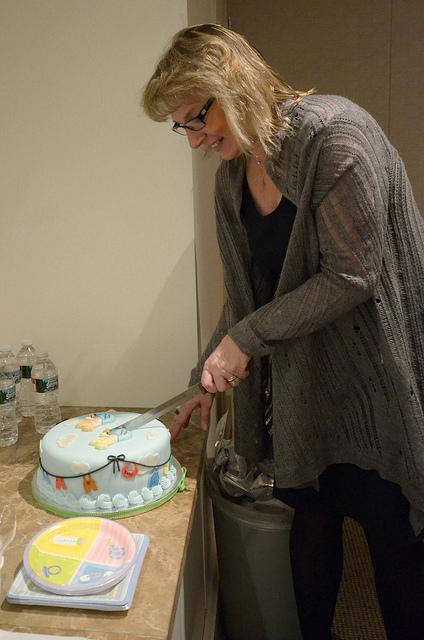What is on the women's face?
Be succinct. Glasses. Is this a homemade cake?
Concise answer only. No. Is the cake blue?
Short answer required. Yes. Is this person cutting a cake?
Quick response, please. Yes. What is the theme of the cake?
Be succinct. Baby. Why is the towel tucked into his apron strings?
Short answer required. Cleaning. Is there a monkey on the cake?
Be succinct. No. Is the woman looking at the camera?
Give a very brief answer. No. 